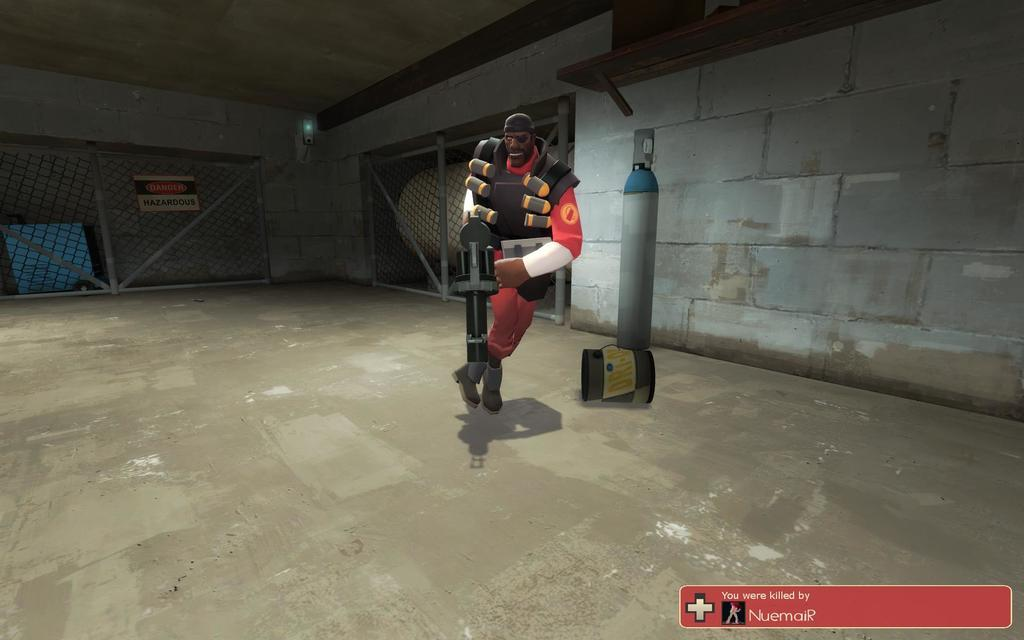What is the person in the image holding? The person is holding a weapon in the image. What can be seen in the background of the image? There is a wall, a shelf, a fence, and a caution board in the background of the image. What type of image is this? The image is animated. Are there any additional elements added to the image? Yes, there is edited text in the image. What type of art can be seen on the wall in the image? There is no art visible on the wall in the image. 